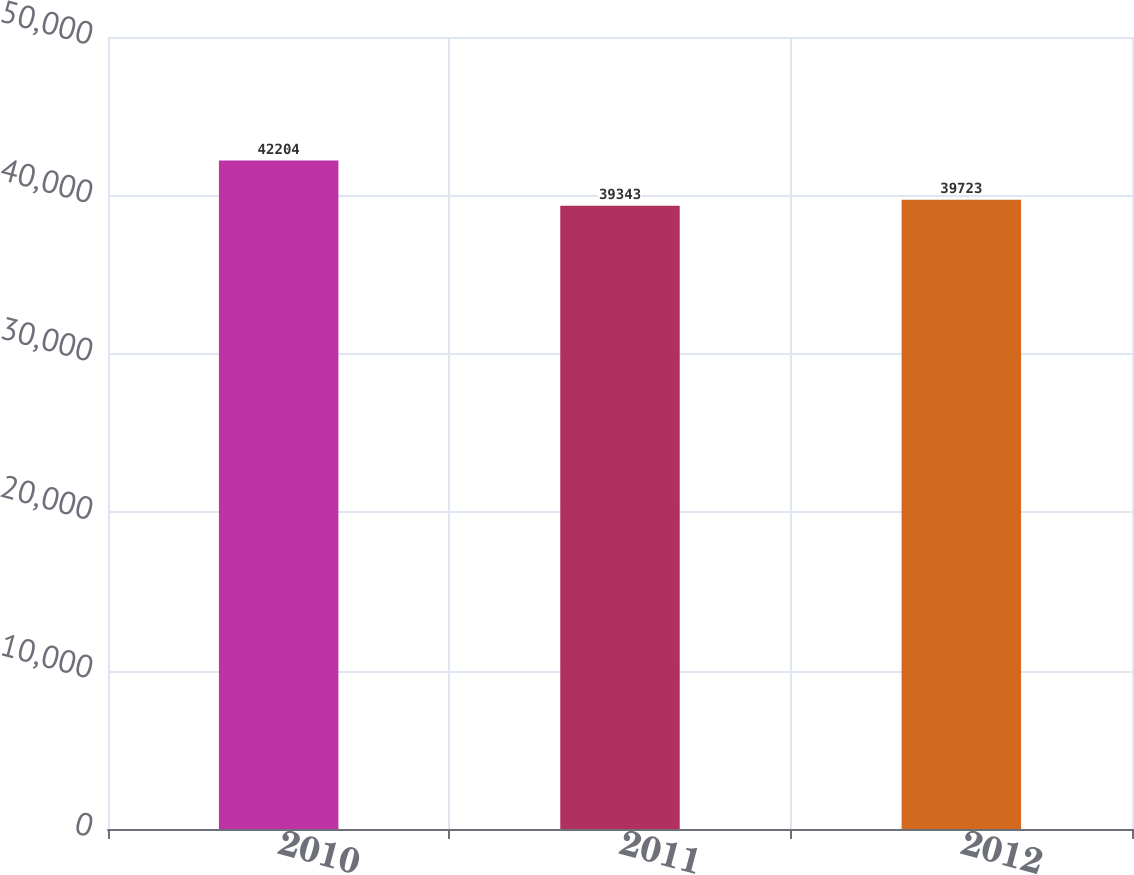<chart> <loc_0><loc_0><loc_500><loc_500><bar_chart><fcel>2010<fcel>2011<fcel>2012<nl><fcel>42204<fcel>39343<fcel>39723<nl></chart> 